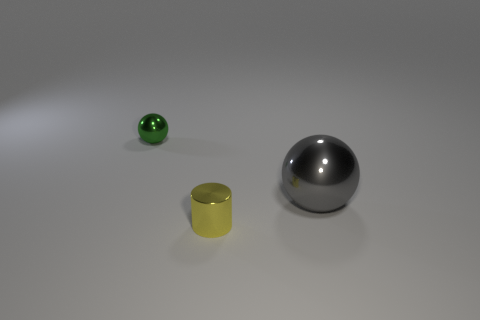What number of things are both to the left of the gray sphere and behind the tiny yellow cylinder?
Make the answer very short. 1. The object that is in front of the gray object to the right of the metallic ball that is on the left side of the large thing is what color?
Provide a short and direct response. Yellow. What number of other things are the same shape as the yellow object?
Your answer should be very brief. 0. Are there any large gray objects to the right of the ball right of the metallic cylinder?
Your answer should be very brief. No. What number of rubber things are yellow objects or small balls?
Provide a short and direct response. 0. There is a object that is both in front of the tiny shiny ball and to the left of the large shiny ball; what is its material?
Your response must be concise. Metal. Is there a metal object to the left of the thing that is behind the ball in front of the green shiny thing?
Your response must be concise. No. What shape is the green object that is the same material as the tiny yellow object?
Offer a very short reply. Sphere. Are there fewer tiny cylinders behind the large metallic ball than tiny shiny things that are on the left side of the small yellow cylinder?
Keep it short and to the point. Yes. How many big objects are blue cubes or cylinders?
Offer a terse response. 0. 